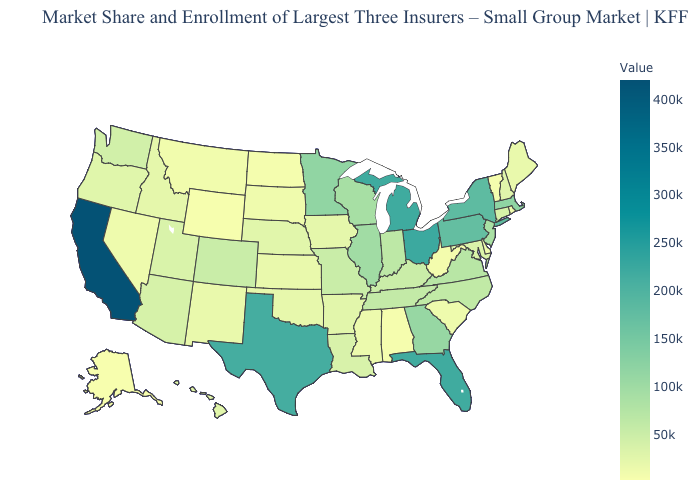Which states hav the highest value in the Northeast?
Concise answer only. New York. Does Maryland have the lowest value in the South?
Concise answer only. No. Which states have the highest value in the USA?
Be succinct. California. Among the states that border Colorado , which have the highest value?
Short answer required. Arizona. 